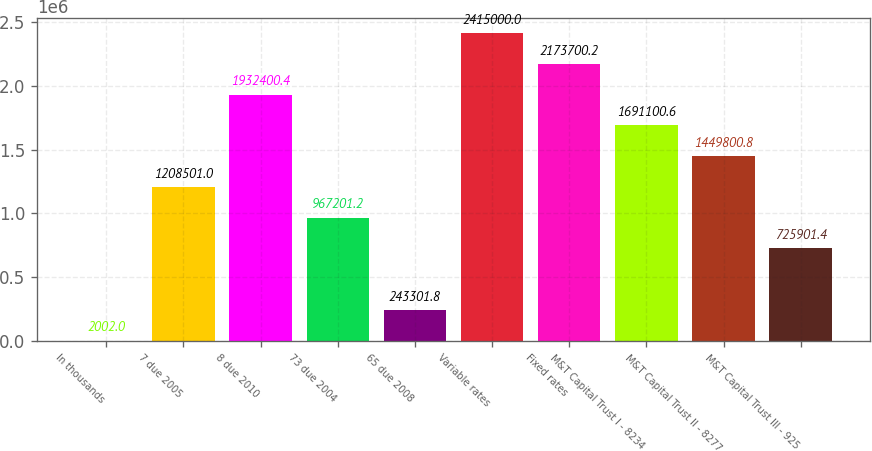<chart> <loc_0><loc_0><loc_500><loc_500><bar_chart><fcel>In thousands<fcel>7 due 2005<fcel>8 due 2010<fcel>73 due 2004<fcel>65 due 2008<fcel>Variable rates<fcel>Fixed rates<fcel>M&T Capital Trust I - 8234<fcel>M&T Capital Trust II - 8277<fcel>M&T Capital Trust III - 925<nl><fcel>2002<fcel>1.2085e+06<fcel>1.9324e+06<fcel>967201<fcel>243302<fcel>2.415e+06<fcel>2.1737e+06<fcel>1.6911e+06<fcel>1.4498e+06<fcel>725901<nl></chart> 